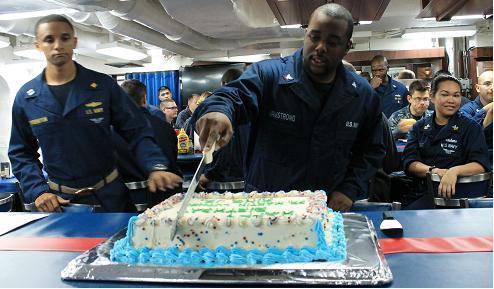How many people are cutting the cake?
Give a very brief answer. 1. How many people are in the photo?
Give a very brief answer. 4. 